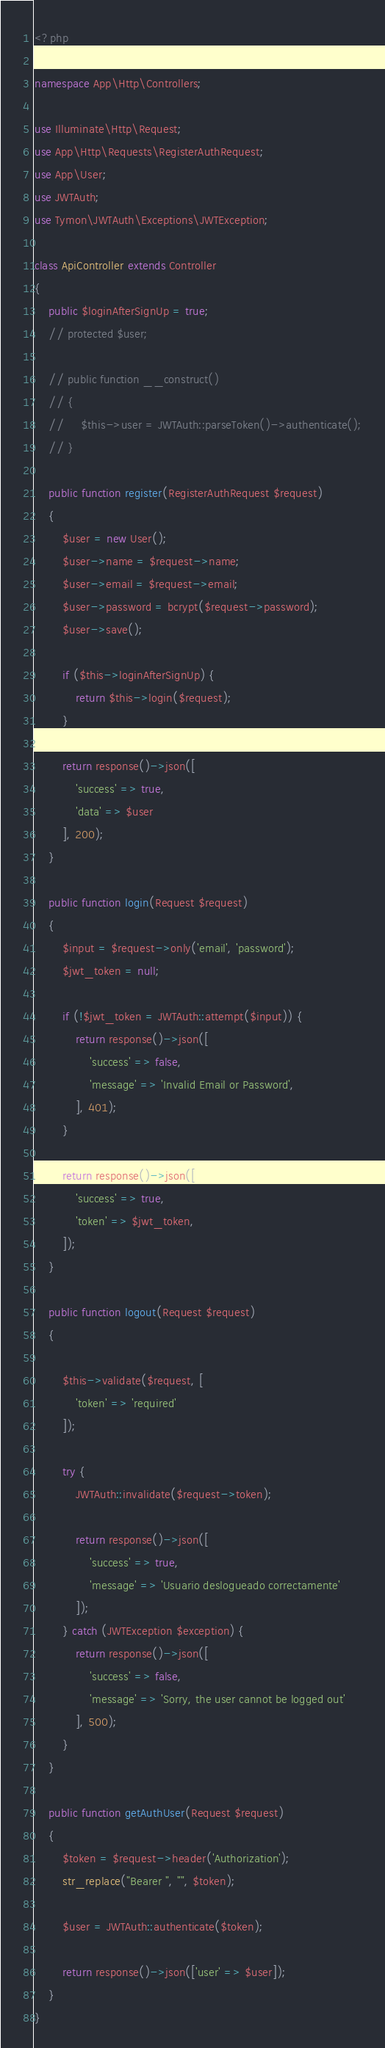Convert code to text. <code><loc_0><loc_0><loc_500><loc_500><_PHP_><?php

namespace App\Http\Controllers;

use Illuminate\Http\Request;
use App\Http\Requests\RegisterAuthRequest;
use App\User;
use JWTAuth;
use Tymon\JWTAuth\Exceptions\JWTException;

class ApiController extends Controller
{
    public $loginAfterSignUp = true;
    // protected $user;
 
    // public function __construct()
    // {
    //     $this->user = JWTAuth::parseToken()->authenticate();
    // }
 
    public function register(RegisterAuthRequest $request)
    {
        $user = new User();
        $user->name = $request->name;
        $user->email = $request->email;
        $user->password = bcrypt($request->password);
        $user->save();
 
        if ($this->loginAfterSignUp) {
            return $this->login($request);
        }
 
        return response()->json([
            'success' => true,
            'data' => $user
        ], 200);
    }
 
    public function login(Request $request)
    {
        $input = $request->only('email', 'password');
        $jwt_token = null;
 
        if (!$jwt_token = JWTAuth::attempt($input)) {
            return response()->json([
                'success' => false,
                'message' => 'Invalid Email or Password',
            ], 401);
        }
 
        return response()->json([
            'success' => true,
            'token' => $jwt_token,
        ]);
    }
 
    public function logout(Request $request)
    {
        
        $this->validate($request, [
            'token' => 'required'
        ]);
 
        try {
            JWTAuth::invalidate($request->token);
 
            return response()->json([
                'success' => true,
                'message' => 'Usuario deslogueado correctamente'
            ]);
        } catch (JWTException $exception) {
            return response()->json([
                'success' => false,
                'message' => 'Sorry, the user cannot be logged out'
            ], 500);
        }
    }
 
    public function getAuthUser(Request $request)
    {       
        $token = $request->header('Authorization');
        str_replace("Bearer ", "", $token);

        $user = JWTAuth::authenticate($token);
 
        return response()->json(['user' => $user]);
    }
}
</code> 